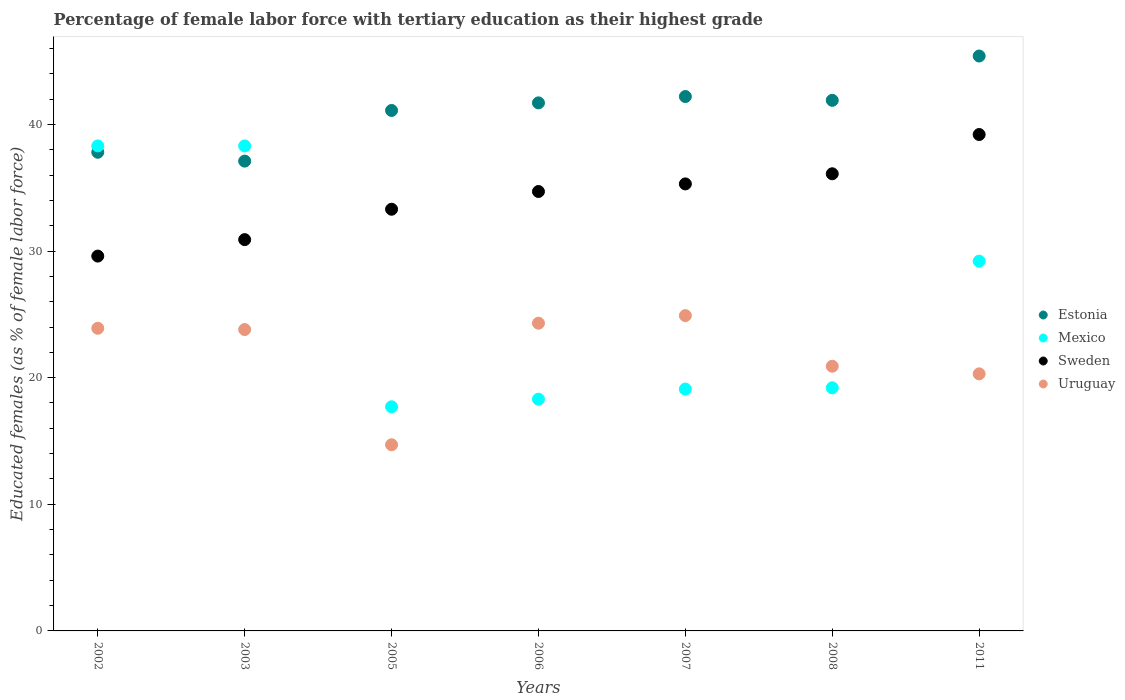What is the percentage of female labor force with tertiary education in Estonia in 2007?
Offer a very short reply. 42.2. Across all years, what is the maximum percentage of female labor force with tertiary education in Uruguay?
Provide a short and direct response. 24.9. Across all years, what is the minimum percentage of female labor force with tertiary education in Estonia?
Your answer should be compact. 37.1. In which year was the percentage of female labor force with tertiary education in Sweden minimum?
Keep it short and to the point. 2002. What is the total percentage of female labor force with tertiary education in Estonia in the graph?
Provide a succinct answer. 287.2. What is the difference between the percentage of female labor force with tertiary education in Mexico in 2005 and that in 2007?
Provide a short and direct response. -1.4. What is the difference between the percentage of female labor force with tertiary education in Uruguay in 2008 and the percentage of female labor force with tertiary education in Estonia in 2007?
Provide a short and direct response. -21.3. What is the average percentage of female labor force with tertiary education in Mexico per year?
Keep it short and to the point. 25.73. In the year 2008, what is the difference between the percentage of female labor force with tertiary education in Estonia and percentage of female labor force with tertiary education in Sweden?
Your answer should be compact. 5.8. What is the ratio of the percentage of female labor force with tertiary education in Sweden in 2002 to that in 2011?
Offer a very short reply. 0.76. Is the difference between the percentage of female labor force with tertiary education in Estonia in 2002 and 2008 greater than the difference between the percentage of female labor force with tertiary education in Sweden in 2002 and 2008?
Make the answer very short. Yes. What is the difference between the highest and the second highest percentage of female labor force with tertiary education in Sweden?
Your response must be concise. 3.1. What is the difference between the highest and the lowest percentage of female labor force with tertiary education in Estonia?
Provide a short and direct response. 8.3. In how many years, is the percentage of female labor force with tertiary education in Mexico greater than the average percentage of female labor force with tertiary education in Mexico taken over all years?
Your response must be concise. 3. Is it the case that in every year, the sum of the percentage of female labor force with tertiary education in Mexico and percentage of female labor force with tertiary education in Estonia  is greater than the percentage of female labor force with tertiary education in Sweden?
Your answer should be very brief. Yes. Is the percentage of female labor force with tertiary education in Sweden strictly greater than the percentage of female labor force with tertiary education in Mexico over the years?
Your answer should be compact. No. Is the percentage of female labor force with tertiary education in Uruguay strictly less than the percentage of female labor force with tertiary education in Estonia over the years?
Your answer should be compact. Yes. How many dotlines are there?
Give a very brief answer. 4. How many years are there in the graph?
Provide a succinct answer. 7. What is the difference between two consecutive major ticks on the Y-axis?
Ensure brevity in your answer.  10. Are the values on the major ticks of Y-axis written in scientific E-notation?
Your answer should be very brief. No. Does the graph contain any zero values?
Provide a succinct answer. No. Does the graph contain grids?
Provide a succinct answer. No. How many legend labels are there?
Provide a short and direct response. 4. What is the title of the graph?
Offer a very short reply. Percentage of female labor force with tertiary education as their highest grade. Does "Middle East & North Africa (all income levels)" appear as one of the legend labels in the graph?
Give a very brief answer. No. What is the label or title of the Y-axis?
Give a very brief answer. Educated females (as % of female labor force). What is the Educated females (as % of female labor force) in Estonia in 2002?
Give a very brief answer. 37.8. What is the Educated females (as % of female labor force) of Mexico in 2002?
Your answer should be very brief. 38.3. What is the Educated females (as % of female labor force) of Sweden in 2002?
Offer a terse response. 29.6. What is the Educated females (as % of female labor force) of Uruguay in 2002?
Provide a short and direct response. 23.9. What is the Educated females (as % of female labor force) of Estonia in 2003?
Provide a succinct answer. 37.1. What is the Educated females (as % of female labor force) of Mexico in 2003?
Your response must be concise. 38.3. What is the Educated females (as % of female labor force) of Sweden in 2003?
Give a very brief answer. 30.9. What is the Educated females (as % of female labor force) of Uruguay in 2003?
Your answer should be very brief. 23.8. What is the Educated females (as % of female labor force) of Estonia in 2005?
Keep it short and to the point. 41.1. What is the Educated females (as % of female labor force) of Mexico in 2005?
Make the answer very short. 17.7. What is the Educated females (as % of female labor force) in Sweden in 2005?
Provide a short and direct response. 33.3. What is the Educated females (as % of female labor force) of Uruguay in 2005?
Provide a succinct answer. 14.7. What is the Educated females (as % of female labor force) of Estonia in 2006?
Offer a terse response. 41.7. What is the Educated females (as % of female labor force) in Mexico in 2006?
Offer a very short reply. 18.3. What is the Educated females (as % of female labor force) in Sweden in 2006?
Ensure brevity in your answer.  34.7. What is the Educated females (as % of female labor force) of Uruguay in 2006?
Your response must be concise. 24.3. What is the Educated females (as % of female labor force) in Estonia in 2007?
Offer a terse response. 42.2. What is the Educated females (as % of female labor force) of Mexico in 2007?
Ensure brevity in your answer.  19.1. What is the Educated females (as % of female labor force) in Sweden in 2007?
Your answer should be compact. 35.3. What is the Educated females (as % of female labor force) in Uruguay in 2007?
Offer a very short reply. 24.9. What is the Educated females (as % of female labor force) in Estonia in 2008?
Give a very brief answer. 41.9. What is the Educated females (as % of female labor force) in Mexico in 2008?
Provide a succinct answer. 19.2. What is the Educated females (as % of female labor force) of Sweden in 2008?
Make the answer very short. 36.1. What is the Educated females (as % of female labor force) in Uruguay in 2008?
Your answer should be compact. 20.9. What is the Educated females (as % of female labor force) in Estonia in 2011?
Keep it short and to the point. 45.4. What is the Educated females (as % of female labor force) of Mexico in 2011?
Offer a very short reply. 29.2. What is the Educated females (as % of female labor force) of Sweden in 2011?
Provide a short and direct response. 39.2. What is the Educated females (as % of female labor force) of Uruguay in 2011?
Your response must be concise. 20.3. Across all years, what is the maximum Educated females (as % of female labor force) of Estonia?
Offer a very short reply. 45.4. Across all years, what is the maximum Educated females (as % of female labor force) in Mexico?
Make the answer very short. 38.3. Across all years, what is the maximum Educated females (as % of female labor force) of Sweden?
Your response must be concise. 39.2. Across all years, what is the maximum Educated females (as % of female labor force) in Uruguay?
Your response must be concise. 24.9. Across all years, what is the minimum Educated females (as % of female labor force) of Estonia?
Offer a very short reply. 37.1. Across all years, what is the minimum Educated females (as % of female labor force) of Mexico?
Offer a very short reply. 17.7. Across all years, what is the minimum Educated females (as % of female labor force) in Sweden?
Provide a short and direct response. 29.6. Across all years, what is the minimum Educated females (as % of female labor force) in Uruguay?
Your answer should be compact. 14.7. What is the total Educated females (as % of female labor force) in Estonia in the graph?
Ensure brevity in your answer.  287.2. What is the total Educated females (as % of female labor force) in Mexico in the graph?
Give a very brief answer. 180.1. What is the total Educated females (as % of female labor force) in Sweden in the graph?
Offer a terse response. 239.1. What is the total Educated females (as % of female labor force) of Uruguay in the graph?
Provide a succinct answer. 152.8. What is the difference between the Educated females (as % of female labor force) in Uruguay in 2002 and that in 2003?
Your answer should be compact. 0.1. What is the difference between the Educated females (as % of female labor force) of Estonia in 2002 and that in 2005?
Give a very brief answer. -3.3. What is the difference between the Educated females (as % of female labor force) in Mexico in 2002 and that in 2005?
Give a very brief answer. 20.6. What is the difference between the Educated females (as % of female labor force) in Sweden in 2002 and that in 2005?
Your answer should be compact. -3.7. What is the difference between the Educated females (as % of female labor force) in Uruguay in 2002 and that in 2005?
Give a very brief answer. 9.2. What is the difference between the Educated females (as % of female labor force) in Mexico in 2002 and that in 2006?
Offer a very short reply. 20. What is the difference between the Educated females (as % of female labor force) of Sweden in 2002 and that in 2006?
Ensure brevity in your answer.  -5.1. What is the difference between the Educated females (as % of female labor force) in Sweden in 2002 and that in 2007?
Offer a terse response. -5.7. What is the difference between the Educated females (as % of female labor force) in Sweden in 2002 and that in 2008?
Your answer should be compact. -6.5. What is the difference between the Educated females (as % of female labor force) of Estonia in 2002 and that in 2011?
Give a very brief answer. -7.6. What is the difference between the Educated females (as % of female labor force) of Mexico in 2002 and that in 2011?
Keep it short and to the point. 9.1. What is the difference between the Educated females (as % of female labor force) of Mexico in 2003 and that in 2005?
Make the answer very short. 20.6. What is the difference between the Educated females (as % of female labor force) of Uruguay in 2003 and that in 2006?
Offer a terse response. -0.5. What is the difference between the Educated females (as % of female labor force) of Mexico in 2003 and that in 2007?
Make the answer very short. 19.2. What is the difference between the Educated females (as % of female labor force) in Sweden in 2003 and that in 2007?
Your response must be concise. -4.4. What is the difference between the Educated females (as % of female labor force) in Sweden in 2003 and that in 2008?
Your answer should be very brief. -5.2. What is the difference between the Educated females (as % of female labor force) in Estonia in 2003 and that in 2011?
Provide a short and direct response. -8.3. What is the difference between the Educated females (as % of female labor force) in Mexico in 2003 and that in 2011?
Provide a succinct answer. 9.1. What is the difference between the Educated females (as % of female labor force) of Sweden in 2003 and that in 2011?
Your response must be concise. -8.3. What is the difference between the Educated females (as % of female labor force) in Uruguay in 2003 and that in 2011?
Give a very brief answer. 3.5. What is the difference between the Educated females (as % of female labor force) in Estonia in 2005 and that in 2006?
Keep it short and to the point. -0.6. What is the difference between the Educated females (as % of female labor force) in Sweden in 2005 and that in 2006?
Your answer should be compact. -1.4. What is the difference between the Educated females (as % of female labor force) of Mexico in 2005 and that in 2007?
Your answer should be compact. -1.4. What is the difference between the Educated females (as % of female labor force) of Sweden in 2005 and that in 2007?
Provide a succinct answer. -2. What is the difference between the Educated females (as % of female labor force) in Uruguay in 2005 and that in 2007?
Give a very brief answer. -10.2. What is the difference between the Educated females (as % of female labor force) of Estonia in 2005 and that in 2008?
Your answer should be compact. -0.8. What is the difference between the Educated females (as % of female labor force) in Sweden in 2005 and that in 2008?
Provide a short and direct response. -2.8. What is the difference between the Educated females (as % of female labor force) of Mexico in 2006 and that in 2007?
Your answer should be very brief. -0.8. What is the difference between the Educated females (as % of female labor force) of Sweden in 2006 and that in 2007?
Provide a short and direct response. -0.6. What is the difference between the Educated females (as % of female labor force) of Uruguay in 2006 and that in 2007?
Keep it short and to the point. -0.6. What is the difference between the Educated females (as % of female labor force) of Estonia in 2006 and that in 2008?
Your answer should be very brief. -0.2. What is the difference between the Educated females (as % of female labor force) of Sweden in 2006 and that in 2008?
Ensure brevity in your answer.  -1.4. What is the difference between the Educated females (as % of female labor force) in Uruguay in 2006 and that in 2008?
Your answer should be very brief. 3.4. What is the difference between the Educated females (as % of female labor force) in Estonia in 2006 and that in 2011?
Offer a very short reply. -3.7. What is the difference between the Educated females (as % of female labor force) of Mexico in 2006 and that in 2011?
Your response must be concise. -10.9. What is the difference between the Educated females (as % of female labor force) in Uruguay in 2006 and that in 2011?
Make the answer very short. 4. What is the difference between the Educated females (as % of female labor force) in Sweden in 2007 and that in 2008?
Your response must be concise. -0.8. What is the difference between the Educated females (as % of female labor force) of Uruguay in 2007 and that in 2008?
Keep it short and to the point. 4. What is the difference between the Educated females (as % of female labor force) in Estonia in 2007 and that in 2011?
Provide a short and direct response. -3.2. What is the difference between the Educated females (as % of female labor force) of Mexico in 2007 and that in 2011?
Ensure brevity in your answer.  -10.1. What is the difference between the Educated females (as % of female labor force) in Uruguay in 2007 and that in 2011?
Offer a very short reply. 4.6. What is the difference between the Educated females (as % of female labor force) of Mexico in 2008 and that in 2011?
Your response must be concise. -10. What is the difference between the Educated females (as % of female labor force) in Estonia in 2002 and the Educated females (as % of female labor force) in Mexico in 2003?
Your response must be concise. -0.5. What is the difference between the Educated females (as % of female labor force) of Estonia in 2002 and the Educated females (as % of female labor force) of Sweden in 2003?
Your answer should be very brief. 6.9. What is the difference between the Educated females (as % of female labor force) of Sweden in 2002 and the Educated females (as % of female labor force) of Uruguay in 2003?
Ensure brevity in your answer.  5.8. What is the difference between the Educated females (as % of female labor force) of Estonia in 2002 and the Educated females (as % of female labor force) of Mexico in 2005?
Offer a very short reply. 20.1. What is the difference between the Educated females (as % of female labor force) of Estonia in 2002 and the Educated females (as % of female labor force) of Sweden in 2005?
Give a very brief answer. 4.5. What is the difference between the Educated females (as % of female labor force) in Estonia in 2002 and the Educated females (as % of female labor force) in Uruguay in 2005?
Ensure brevity in your answer.  23.1. What is the difference between the Educated females (as % of female labor force) in Mexico in 2002 and the Educated females (as % of female labor force) in Uruguay in 2005?
Your response must be concise. 23.6. What is the difference between the Educated females (as % of female labor force) of Estonia in 2002 and the Educated females (as % of female labor force) of Mexico in 2006?
Ensure brevity in your answer.  19.5. What is the difference between the Educated females (as % of female labor force) of Estonia in 2002 and the Educated females (as % of female labor force) of Sweden in 2006?
Your answer should be compact. 3.1. What is the difference between the Educated females (as % of female labor force) in Estonia in 2002 and the Educated females (as % of female labor force) in Uruguay in 2006?
Make the answer very short. 13.5. What is the difference between the Educated females (as % of female labor force) in Sweden in 2002 and the Educated females (as % of female labor force) in Uruguay in 2006?
Your response must be concise. 5.3. What is the difference between the Educated females (as % of female labor force) in Estonia in 2002 and the Educated females (as % of female labor force) in Uruguay in 2007?
Offer a very short reply. 12.9. What is the difference between the Educated females (as % of female labor force) of Mexico in 2002 and the Educated females (as % of female labor force) of Sweden in 2007?
Provide a short and direct response. 3. What is the difference between the Educated females (as % of female labor force) in Mexico in 2002 and the Educated females (as % of female labor force) in Uruguay in 2007?
Provide a short and direct response. 13.4. What is the difference between the Educated females (as % of female labor force) in Sweden in 2002 and the Educated females (as % of female labor force) in Uruguay in 2007?
Your answer should be very brief. 4.7. What is the difference between the Educated females (as % of female labor force) in Mexico in 2002 and the Educated females (as % of female labor force) in Sweden in 2008?
Offer a very short reply. 2.2. What is the difference between the Educated females (as % of female labor force) of Mexico in 2002 and the Educated females (as % of female labor force) of Uruguay in 2008?
Give a very brief answer. 17.4. What is the difference between the Educated females (as % of female labor force) of Estonia in 2002 and the Educated females (as % of female labor force) of Sweden in 2011?
Offer a very short reply. -1.4. What is the difference between the Educated females (as % of female labor force) in Estonia in 2002 and the Educated females (as % of female labor force) in Uruguay in 2011?
Your answer should be very brief. 17.5. What is the difference between the Educated females (as % of female labor force) in Estonia in 2003 and the Educated females (as % of female labor force) in Uruguay in 2005?
Your response must be concise. 22.4. What is the difference between the Educated females (as % of female labor force) in Mexico in 2003 and the Educated females (as % of female labor force) in Uruguay in 2005?
Your response must be concise. 23.6. What is the difference between the Educated females (as % of female labor force) of Estonia in 2003 and the Educated females (as % of female labor force) of Mexico in 2006?
Make the answer very short. 18.8. What is the difference between the Educated females (as % of female labor force) of Estonia in 2003 and the Educated females (as % of female labor force) of Uruguay in 2006?
Provide a short and direct response. 12.8. What is the difference between the Educated females (as % of female labor force) of Mexico in 2003 and the Educated females (as % of female labor force) of Sweden in 2006?
Your answer should be compact. 3.6. What is the difference between the Educated females (as % of female labor force) in Mexico in 2003 and the Educated females (as % of female labor force) in Uruguay in 2006?
Offer a terse response. 14. What is the difference between the Educated females (as % of female labor force) in Sweden in 2003 and the Educated females (as % of female labor force) in Uruguay in 2006?
Make the answer very short. 6.6. What is the difference between the Educated females (as % of female labor force) of Estonia in 2003 and the Educated females (as % of female labor force) of Mexico in 2007?
Ensure brevity in your answer.  18. What is the difference between the Educated females (as % of female labor force) of Estonia in 2003 and the Educated females (as % of female labor force) of Sweden in 2007?
Offer a very short reply. 1.8. What is the difference between the Educated females (as % of female labor force) in Sweden in 2003 and the Educated females (as % of female labor force) in Uruguay in 2007?
Keep it short and to the point. 6. What is the difference between the Educated females (as % of female labor force) in Estonia in 2003 and the Educated females (as % of female labor force) in Uruguay in 2008?
Make the answer very short. 16.2. What is the difference between the Educated females (as % of female labor force) of Mexico in 2003 and the Educated females (as % of female labor force) of Sweden in 2008?
Provide a short and direct response. 2.2. What is the difference between the Educated females (as % of female labor force) of Sweden in 2003 and the Educated females (as % of female labor force) of Uruguay in 2008?
Offer a terse response. 10. What is the difference between the Educated females (as % of female labor force) in Estonia in 2003 and the Educated females (as % of female labor force) in Mexico in 2011?
Provide a short and direct response. 7.9. What is the difference between the Educated females (as % of female labor force) of Mexico in 2003 and the Educated females (as % of female labor force) of Uruguay in 2011?
Your response must be concise. 18. What is the difference between the Educated females (as % of female labor force) of Sweden in 2003 and the Educated females (as % of female labor force) of Uruguay in 2011?
Your answer should be very brief. 10.6. What is the difference between the Educated females (as % of female labor force) in Estonia in 2005 and the Educated females (as % of female labor force) in Mexico in 2006?
Offer a terse response. 22.8. What is the difference between the Educated females (as % of female labor force) of Estonia in 2005 and the Educated females (as % of female labor force) of Sweden in 2006?
Give a very brief answer. 6.4. What is the difference between the Educated females (as % of female labor force) of Mexico in 2005 and the Educated females (as % of female labor force) of Sweden in 2006?
Your answer should be very brief. -17. What is the difference between the Educated females (as % of female labor force) in Sweden in 2005 and the Educated females (as % of female labor force) in Uruguay in 2006?
Provide a short and direct response. 9. What is the difference between the Educated females (as % of female labor force) of Estonia in 2005 and the Educated females (as % of female labor force) of Mexico in 2007?
Give a very brief answer. 22. What is the difference between the Educated females (as % of female labor force) in Mexico in 2005 and the Educated females (as % of female labor force) in Sweden in 2007?
Your response must be concise. -17.6. What is the difference between the Educated females (as % of female labor force) of Estonia in 2005 and the Educated females (as % of female labor force) of Mexico in 2008?
Make the answer very short. 21.9. What is the difference between the Educated females (as % of female labor force) in Estonia in 2005 and the Educated females (as % of female labor force) in Uruguay in 2008?
Provide a succinct answer. 20.2. What is the difference between the Educated females (as % of female labor force) of Mexico in 2005 and the Educated females (as % of female labor force) of Sweden in 2008?
Your response must be concise. -18.4. What is the difference between the Educated females (as % of female labor force) in Sweden in 2005 and the Educated females (as % of female labor force) in Uruguay in 2008?
Your response must be concise. 12.4. What is the difference between the Educated females (as % of female labor force) of Estonia in 2005 and the Educated females (as % of female labor force) of Uruguay in 2011?
Provide a short and direct response. 20.8. What is the difference between the Educated females (as % of female labor force) of Mexico in 2005 and the Educated females (as % of female labor force) of Sweden in 2011?
Your answer should be compact. -21.5. What is the difference between the Educated females (as % of female labor force) in Sweden in 2005 and the Educated females (as % of female labor force) in Uruguay in 2011?
Give a very brief answer. 13. What is the difference between the Educated females (as % of female labor force) in Estonia in 2006 and the Educated females (as % of female labor force) in Mexico in 2007?
Make the answer very short. 22.6. What is the difference between the Educated females (as % of female labor force) in Estonia in 2006 and the Educated females (as % of female labor force) in Sweden in 2007?
Your response must be concise. 6.4. What is the difference between the Educated females (as % of female labor force) in Mexico in 2006 and the Educated females (as % of female labor force) in Sweden in 2007?
Ensure brevity in your answer.  -17. What is the difference between the Educated females (as % of female labor force) in Sweden in 2006 and the Educated females (as % of female labor force) in Uruguay in 2007?
Offer a very short reply. 9.8. What is the difference between the Educated females (as % of female labor force) of Estonia in 2006 and the Educated females (as % of female labor force) of Sweden in 2008?
Keep it short and to the point. 5.6. What is the difference between the Educated females (as % of female labor force) of Estonia in 2006 and the Educated females (as % of female labor force) of Uruguay in 2008?
Provide a succinct answer. 20.8. What is the difference between the Educated females (as % of female labor force) in Mexico in 2006 and the Educated females (as % of female labor force) in Sweden in 2008?
Offer a very short reply. -17.8. What is the difference between the Educated females (as % of female labor force) in Mexico in 2006 and the Educated females (as % of female labor force) in Uruguay in 2008?
Make the answer very short. -2.6. What is the difference between the Educated females (as % of female labor force) of Estonia in 2006 and the Educated females (as % of female labor force) of Mexico in 2011?
Provide a succinct answer. 12.5. What is the difference between the Educated females (as % of female labor force) in Estonia in 2006 and the Educated females (as % of female labor force) in Sweden in 2011?
Your answer should be compact. 2.5. What is the difference between the Educated females (as % of female labor force) in Estonia in 2006 and the Educated females (as % of female labor force) in Uruguay in 2011?
Offer a very short reply. 21.4. What is the difference between the Educated females (as % of female labor force) of Mexico in 2006 and the Educated females (as % of female labor force) of Sweden in 2011?
Give a very brief answer. -20.9. What is the difference between the Educated females (as % of female labor force) of Mexico in 2006 and the Educated females (as % of female labor force) of Uruguay in 2011?
Offer a terse response. -2. What is the difference between the Educated females (as % of female labor force) of Estonia in 2007 and the Educated females (as % of female labor force) of Sweden in 2008?
Provide a short and direct response. 6.1. What is the difference between the Educated females (as % of female labor force) in Estonia in 2007 and the Educated females (as % of female labor force) in Uruguay in 2008?
Your response must be concise. 21.3. What is the difference between the Educated females (as % of female labor force) in Mexico in 2007 and the Educated females (as % of female labor force) in Sweden in 2008?
Keep it short and to the point. -17. What is the difference between the Educated females (as % of female labor force) of Mexico in 2007 and the Educated females (as % of female labor force) of Uruguay in 2008?
Make the answer very short. -1.8. What is the difference between the Educated females (as % of female labor force) of Estonia in 2007 and the Educated females (as % of female labor force) of Mexico in 2011?
Your answer should be compact. 13. What is the difference between the Educated females (as % of female labor force) of Estonia in 2007 and the Educated females (as % of female labor force) of Sweden in 2011?
Make the answer very short. 3. What is the difference between the Educated females (as % of female labor force) in Estonia in 2007 and the Educated females (as % of female labor force) in Uruguay in 2011?
Make the answer very short. 21.9. What is the difference between the Educated females (as % of female labor force) in Mexico in 2007 and the Educated females (as % of female labor force) in Sweden in 2011?
Give a very brief answer. -20.1. What is the difference between the Educated females (as % of female labor force) in Estonia in 2008 and the Educated females (as % of female labor force) in Mexico in 2011?
Offer a terse response. 12.7. What is the difference between the Educated females (as % of female labor force) of Estonia in 2008 and the Educated females (as % of female labor force) of Sweden in 2011?
Give a very brief answer. 2.7. What is the difference between the Educated females (as % of female labor force) in Estonia in 2008 and the Educated females (as % of female labor force) in Uruguay in 2011?
Your response must be concise. 21.6. What is the difference between the Educated females (as % of female labor force) in Sweden in 2008 and the Educated females (as % of female labor force) in Uruguay in 2011?
Your answer should be compact. 15.8. What is the average Educated females (as % of female labor force) of Estonia per year?
Your answer should be compact. 41.03. What is the average Educated females (as % of female labor force) of Mexico per year?
Your response must be concise. 25.73. What is the average Educated females (as % of female labor force) of Sweden per year?
Your answer should be very brief. 34.16. What is the average Educated females (as % of female labor force) in Uruguay per year?
Make the answer very short. 21.83. In the year 2002, what is the difference between the Educated females (as % of female labor force) of Estonia and Educated females (as % of female labor force) of Uruguay?
Offer a very short reply. 13.9. In the year 2002, what is the difference between the Educated females (as % of female labor force) in Sweden and Educated females (as % of female labor force) in Uruguay?
Your response must be concise. 5.7. In the year 2003, what is the difference between the Educated females (as % of female labor force) in Estonia and Educated females (as % of female labor force) in Mexico?
Offer a terse response. -1.2. In the year 2003, what is the difference between the Educated females (as % of female labor force) in Estonia and Educated females (as % of female labor force) in Sweden?
Give a very brief answer. 6.2. In the year 2003, what is the difference between the Educated females (as % of female labor force) in Estonia and Educated females (as % of female labor force) in Uruguay?
Make the answer very short. 13.3. In the year 2003, what is the difference between the Educated females (as % of female labor force) in Mexico and Educated females (as % of female labor force) in Uruguay?
Offer a terse response. 14.5. In the year 2005, what is the difference between the Educated females (as % of female labor force) in Estonia and Educated females (as % of female labor force) in Mexico?
Ensure brevity in your answer.  23.4. In the year 2005, what is the difference between the Educated females (as % of female labor force) of Estonia and Educated females (as % of female labor force) of Sweden?
Provide a short and direct response. 7.8. In the year 2005, what is the difference between the Educated females (as % of female labor force) of Estonia and Educated females (as % of female labor force) of Uruguay?
Make the answer very short. 26.4. In the year 2005, what is the difference between the Educated females (as % of female labor force) in Mexico and Educated females (as % of female labor force) in Sweden?
Offer a terse response. -15.6. In the year 2006, what is the difference between the Educated females (as % of female labor force) in Estonia and Educated females (as % of female labor force) in Mexico?
Your answer should be very brief. 23.4. In the year 2006, what is the difference between the Educated females (as % of female labor force) of Estonia and Educated females (as % of female labor force) of Sweden?
Your answer should be compact. 7. In the year 2006, what is the difference between the Educated females (as % of female labor force) in Mexico and Educated females (as % of female labor force) in Sweden?
Provide a short and direct response. -16.4. In the year 2006, what is the difference between the Educated females (as % of female labor force) of Sweden and Educated females (as % of female labor force) of Uruguay?
Provide a succinct answer. 10.4. In the year 2007, what is the difference between the Educated females (as % of female labor force) in Estonia and Educated females (as % of female labor force) in Mexico?
Provide a succinct answer. 23.1. In the year 2007, what is the difference between the Educated females (as % of female labor force) in Estonia and Educated females (as % of female labor force) in Sweden?
Your response must be concise. 6.9. In the year 2007, what is the difference between the Educated females (as % of female labor force) of Estonia and Educated females (as % of female labor force) of Uruguay?
Make the answer very short. 17.3. In the year 2007, what is the difference between the Educated females (as % of female labor force) in Mexico and Educated females (as % of female labor force) in Sweden?
Make the answer very short. -16.2. In the year 2007, what is the difference between the Educated females (as % of female labor force) of Mexico and Educated females (as % of female labor force) of Uruguay?
Your answer should be very brief. -5.8. In the year 2007, what is the difference between the Educated females (as % of female labor force) in Sweden and Educated females (as % of female labor force) in Uruguay?
Ensure brevity in your answer.  10.4. In the year 2008, what is the difference between the Educated females (as % of female labor force) of Estonia and Educated females (as % of female labor force) of Mexico?
Make the answer very short. 22.7. In the year 2008, what is the difference between the Educated females (as % of female labor force) of Estonia and Educated females (as % of female labor force) of Sweden?
Make the answer very short. 5.8. In the year 2008, what is the difference between the Educated females (as % of female labor force) in Estonia and Educated females (as % of female labor force) in Uruguay?
Provide a short and direct response. 21. In the year 2008, what is the difference between the Educated females (as % of female labor force) of Mexico and Educated females (as % of female labor force) of Sweden?
Keep it short and to the point. -16.9. In the year 2008, what is the difference between the Educated females (as % of female labor force) of Mexico and Educated females (as % of female labor force) of Uruguay?
Your answer should be compact. -1.7. In the year 2011, what is the difference between the Educated females (as % of female labor force) of Estonia and Educated females (as % of female labor force) of Uruguay?
Offer a very short reply. 25.1. What is the ratio of the Educated females (as % of female labor force) in Estonia in 2002 to that in 2003?
Your answer should be compact. 1.02. What is the ratio of the Educated females (as % of female labor force) of Sweden in 2002 to that in 2003?
Offer a very short reply. 0.96. What is the ratio of the Educated females (as % of female labor force) of Estonia in 2002 to that in 2005?
Provide a short and direct response. 0.92. What is the ratio of the Educated females (as % of female labor force) in Mexico in 2002 to that in 2005?
Your response must be concise. 2.16. What is the ratio of the Educated females (as % of female labor force) in Sweden in 2002 to that in 2005?
Offer a very short reply. 0.89. What is the ratio of the Educated females (as % of female labor force) in Uruguay in 2002 to that in 2005?
Ensure brevity in your answer.  1.63. What is the ratio of the Educated females (as % of female labor force) of Estonia in 2002 to that in 2006?
Your response must be concise. 0.91. What is the ratio of the Educated females (as % of female labor force) of Mexico in 2002 to that in 2006?
Keep it short and to the point. 2.09. What is the ratio of the Educated females (as % of female labor force) in Sweden in 2002 to that in 2006?
Offer a terse response. 0.85. What is the ratio of the Educated females (as % of female labor force) of Uruguay in 2002 to that in 2006?
Keep it short and to the point. 0.98. What is the ratio of the Educated females (as % of female labor force) in Estonia in 2002 to that in 2007?
Provide a short and direct response. 0.9. What is the ratio of the Educated females (as % of female labor force) in Mexico in 2002 to that in 2007?
Provide a succinct answer. 2.01. What is the ratio of the Educated females (as % of female labor force) of Sweden in 2002 to that in 2007?
Provide a short and direct response. 0.84. What is the ratio of the Educated females (as % of female labor force) in Uruguay in 2002 to that in 2007?
Your response must be concise. 0.96. What is the ratio of the Educated females (as % of female labor force) in Estonia in 2002 to that in 2008?
Provide a short and direct response. 0.9. What is the ratio of the Educated females (as % of female labor force) of Mexico in 2002 to that in 2008?
Provide a succinct answer. 1.99. What is the ratio of the Educated females (as % of female labor force) of Sweden in 2002 to that in 2008?
Your answer should be compact. 0.82. What is the ratio of the Educated females (as % of female labor force) in Uruguay in 2002 to that in 2008?
Your response must be concise. 1.14. What is the ratio of the Educated females (as % of female labor force) in Estonia in 2002 to that in 2011?
Your answer should be very brief. 0.83. What is the ratio of the Educated females (as % of female labor force) of Mexico in 2002 to that in 2011?
Provide a short and direct response. 1.31. What is the ratio of the Educated females (as % of female labor force) of Sweden in 2002 to that in 2011?
Provide a short and direct response. 0.76. What is the ratio of the Educated females (as % of female labor force) of Uruguay in 2002 to that in 2011?
Ensure brevity in your answer.  1.18. What is the ratio of the Educated females (as % of female labor force) of Estonia in 2003 to that in 2005?
Provide a succinct answer. 0.9. What is the ratio of the Educated females (as % of female labor force) in Mexico in 2003 to that in 2005?
Give a very brief answer. 2.16. What is the ratio of the Educated females (as % of female labor force) of Sweden in 2003 to that in 2005?
Give a very brief answer. 0.93. What is the ratio of the Educated females (as % of female labor force) of Uruguay in 2003 to that in 2005?
Provide a short and direct response. 1.62. What is the ratio of the Educated females (as % of female labor force) in Estonia in 2003 to that in 2006?
Your response must be concise. 0.89. What is the ratio of the Educated females (as % of female labor force) in Mexico in 2003 to that in 2006?
Provide a succinct answer. 2.09. What is the ratio of the Educated females (as % of female labor force) of Sweden in 2003 to that in 2006?
Your answer should be very brief. 0.89. What is the ratio of the Educated females (as % of female labor force) in Uruguay in 2003 to that in 2006?
Ensure brevity in your answer.  0.98. What is the ratio of the Educated females (as % of female labor force) in Estonia in 2003 to that in 2007?
Provide a succinct answer. 0.88. What is the ratio of the Educated females (as % of female labor force) in Mexico in 2003 to that in 2007?
Your answer should be compact. 2.01. What is the ratio of the Educated females (as % of female labor force) of Sweden in 2003 to that in 2007?
Your answer should be compact. 0.88. What is the ratio of the Educated females (as % of female labor force) of Uruguay in 2003 to that in 2007?
Provide a short and direct response. 0.96. What is the ratio of the Educated females (as % of female labor force) in Estonia in 2003 to that in 2008?
Offer a very short reply. 0.89. What is the ratio of the Educated females (as % of female labor force) of Mexico in 2003 to that in 2008?
Your answer should be compact. 1.99. What is the ratio of the Educated females (as % of female labor force) in Sweden in 2003 to that in 2008?
Keep it short and to the point. 0.86. What is the ratio of the Educated females (as % of female labor force) of Uruguay in 2003 to that in 2008?
Provide a succinct answer. 1.14. What is the ratio of the Educated females (as % of female labor force) of Estonia in 2003 to that in 2011?
Offer a terse response. 0.82. What is the ratio of the Educated females (as % of female labor force) in Mexico in 2003 to that in 2011?
Ensure brevity in your answer.  1.31. What is the ratio of the Educated females (as % of female labor force) of Sweden in 2003 to that in 2011?
Give a very brief answer. 0.79. What is the ratio of the Educated females (as % of female labor force) in Uruguay in 2003 to that in 2011?
Ensure brevity in your answer.  1.17. What is the ratio of the Educated females (as % of female labor force) of Estonia in 2005 to that in 2006?
Give a very brief answer. 0.99. What is the ratio of the Educated females (as % of female labor force) of Mexico in 2005 to that in 2006?
Ensure brevity in your answer.  0.97. What is the ratio of the Educated females (as % of female labor force) in Sweden in 2005 to that in 2006?
Make the answer very short. 0.96. What is the ratio of the Educated females (as % of female labor force) in Uruguay in 2005 to that in 2006?
Offer a very short reply. 0.6. What is the ratio of the Educated females (as % of female labor force) in Estonia in 2005 to that in 2007?
Provide a succinct answer. 0.97. What is the ratio of the Educated females (as % of female labor force) in Mexico in 2005 to that in 2007?
Provide a succinct answer. 0.93. What is the ratio of the Educated females (as % of female labor force) of Sweden in 2005 to that in 2007?
Ensure brevity in your answer.  0.94. What is the ratio of the Educated females (as % of female labor force) of Uruguay in 2005 to that in 2007?
Offer a very short reply. 0.59. What is the ratio of the Educated females (as % of female labor force) in Estonia in 2005 to that in 2008?
Offer a terse response. 0.98. What is the ratio of the Educated females (as % of female labor force) of Mexico in 2005 to that in 2008?
Offer a terse response. 0.92. What is the ratio of the Educated females (as % of female labor force) of Sweden in 2005 to that in 2008?
Your response must be concise. 0.92. What is the ratio of the Educated females (as % of female labor force) in Uruguay in 2005 to that in 2008?
Keep it short and to the point. 0.7. What is the ratio of the Educated females (as % of female labor force) of Estonia in 2005 to that in 2011?
Ensure brevity in your answer.  0.91. What is the ratio of the Educated females (as % of female labor force) in Mexico in 2005 to that in 2011?
Ensure brevity in your answer.  0.61. What is the ratio of the Educated females (as % of female labor force) of Sweden in 2005 to that in 2011?
Your answer should be compact. 0.85. What is the ratio of the Educated females (as % of female labor force) in Uruguay in 2005 to that in 2011?
Your response must be concise. 0.72. What is the ratio of the Educated females (as % of female labor force) in Estonia in 2006 to that in 2007?
Your answer should be very brief. 0.99. What is the ratio of the Educated females (as % of female labor force) in Mexico in 2006 to that in 2007?
Keep it short and to the point. 0.96. What is the ratio of the Educated females (as % of female labor force) in Sweden in 2006 to that in 2007?
Your answer should be compact. 0.98. What is the ratio of the Educated females (as % of female labor force) of Uruguay in 2006 to that in 2007?
Ensure brevity in your answer.  0.98. What is the ratio of the Educated females (as % of female labor force) in Estonia in 2006 to that in 2008?
Make the answer very short. 1. What is the ratio of the Educated females (as % of female labor force) of Mexico in 2006 to that in 2008?
Make the answer very short. 0.95. What is the ratio of the Educated females (as % of female labor force) in Sweden in 2006 to that in 2008?
Keep it short and to the point. 0.96. What is the ratio of the Educated females (as % of female labor force) in Uruguay in 2006 to that in 2008?
Offer a terse response. 1.16. What is the ratio of the Educated females (as % of female labor force) in Estonia in 2006 to that in 2011?
Provide a succinct answer. 0.92. What is the ratio of the Educated females (as % of female labor force) in Mexico in 2006 to that in 2011?
Offer a very short reply. 0.63. What is the ratio of the Educated females (as % of female labor force) of Sweden in 2006 to that in 2011?
Give a very brief answer. 0.89. What is the ratio of the Educated females (as % of female labor force) of Uruguay in 2006 to that in 2011?
Your answer should be very brief. 1.2. What is the ratio of the Educated females (as % of female labor force) of Mexico in 2007 to that in 2008?
Provide a succinct answer. 0.99. What is the ratio of the Educated females (as % of female labor force) in Sweden in 2007 to that in 2008?
Make the answer very short. 0.98. What is the ratio of the Educated females (as % of female labor force) in Uruguay in 2007 to that in 2008?
Provide a succinct answer. 1.19. What is the ratio of the Educated females (as % of female labor force) of Estonia in 2007 to that in 2011?
Provide a short and direct response. 0.93. What is the ratio of the Educated females (as % of female labor force) in Mexico in 2007 to that in 2011?
Keep it short and to the point. 0.65. What is the ratio of the Educated females (as % of female labor force) in Sweden in 2007 to that in 2011?
Make the answer very short. 0.9. What is the ratio of the Educated females (as % of female labor force) of Uruguay in 2007 to that in 2011?
Provide a succinct answer. 1.23. What is the ratio of the Educated females (as % of female labor force) in Estonia in 2008 to that in 2011?
Ensure brevity in your answer.  0.92. What is the ratio of the Educated females (as % of female labor force) of Mexico in 2008 to that in 2011?
Make the answer very short. 0.66. What is the ratio of the Educated females (as % of female labor force) in Sweden in 2008 to that in 2011?
Offer a terse response. 0.92. What is the ratio of the Educated females (as % of female labor force) of Uruguay in 2008 to that in 2011?
Your answer should be very brief. 1.03. What is the difference between the highest and the second highest Educated females (as % of female labor force) of Uruguay?
Keep it short and to the point. 0.6. What is the difference between the highest and the lowest Educated females (as % of female labor force) in Mexico?
Provide a succinct answer. 20.6. What is the difference between the highest and the lowest Educated females (as % of female labor force) of Sweden?
Offer a terse response. 9.6. What is the difference between the highest and the lowest Educated females (as % of female labor force) in Uruguay?
Ensure brevity in your answer.  10.2. 